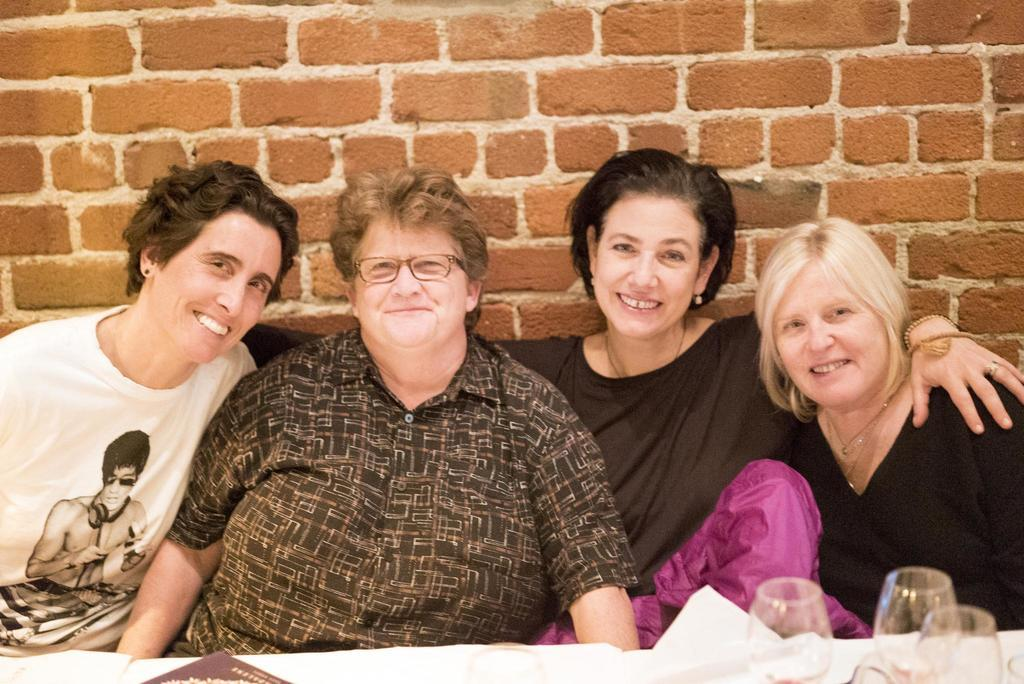How many ladies are in the image? There are four ladies in the image. What are the ladies doing in the image? The ladies are sitting on chairs and smiling. What is present on the table in front of the ladies? There is paper and glasses on the table. What can be seen in the background of the image? There is a wall in the background of the image. What is the reason behind the ladies playing chess in the image? There is no chess game present in the image, so we cannot determine the reason behind any such activity. 